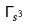Convert formula to latex. <formula><loc_0><loc_0><loc_500><loc_500>\Gamma _ { s ^ { 3 } }</formula> 